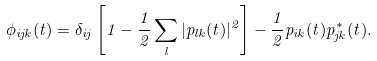Convert formula to latex. <formula><loc_0><loc_0><loc_500><loc_500>\phi _ { i j { k } } ( t ) = \delta _ { i j } \left [ 1 - \frac { 1 } { 2 } \sum _ { l } | p _ { l { k } } ( t ) | ^ { 2 } \right ] - \frac { 1 } { 2 } p _ { i { k } } ( t ) p _ { j { k } } ^ { \ast } ( t ) .</formula> 